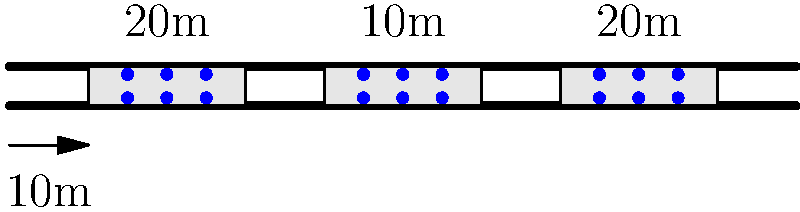Given the scaled diagram of a street with micro-mobility parking zones, estimate the total area required for parking if the city needs to accommodate 200 e-scooters. Assume each scooter requires 1 square meter of space and the parking zones are rectangular with a width of 5 meters. Round your answer to the nearest 10 square meters. To solve this problem, let's follow these steps:

1. Determine the scale of the diagram:
   The scale shows that 10m is represented by the length of the arrow at the bottom.

2. Calculate the total length of parking zones:
   There are three parking zones: two 20m long and one 10m long.
   Total length = $20m + 20m + 10m = 50m$

3. Calculate the total area of the existing parking zones:
   Width of each zone = 5m
   Total area = $50m \times 5m = 250$ square meters

4. Count the number of scooters in the diagram:
   Each zone shows 6 scooters, and there are 3 zones.
   Total scooters shown = $6 \times 3 = 18$ scooters

5. Calculate the area required for 200 scooters:
   Each scooter requires 1 square meter.
   Area required = $200 \times 1$ square meter = 200 square meters

6. Round the result to the nearest 10 square meters:
   200 square meters is already a multiple of 10, so no rounding is needed.

Therefore, the estimated area required for parking 200 e-scooters is 200 square meters.
Answer: 200 square meters 